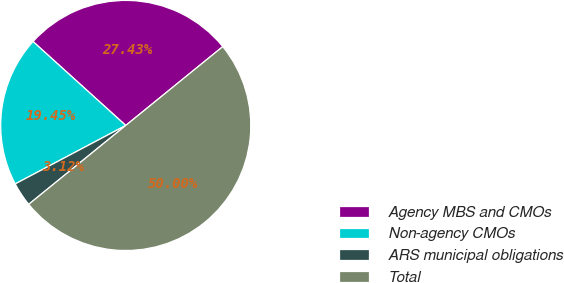<chart> <loc_0><loc_0><loc_500><loc_500><pie_chart><fcel>Agency MBS and CMOs<fcel>Non-agency CMOs<fcel>ARS municipal obligations<fcel>Total<nl><fcel>27.43%<fcel>19.45%<fcel>3.12%<fcel>50.0%<nl></chart> 